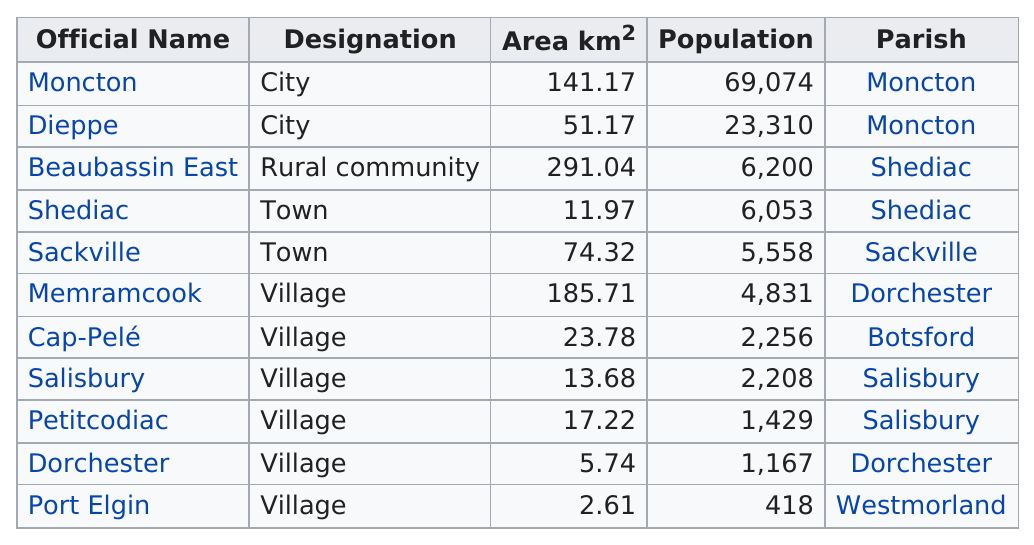Highlight a few significant elements in this photo. Port Elgin has the least area among all cities. Beaubassin East is the only rural community listed. Port Elgin is the village with the smallest land area. The city of Moncton and Dieppe are both located in the same parish. Moncton has the largest population among all the municipalities in the area. 